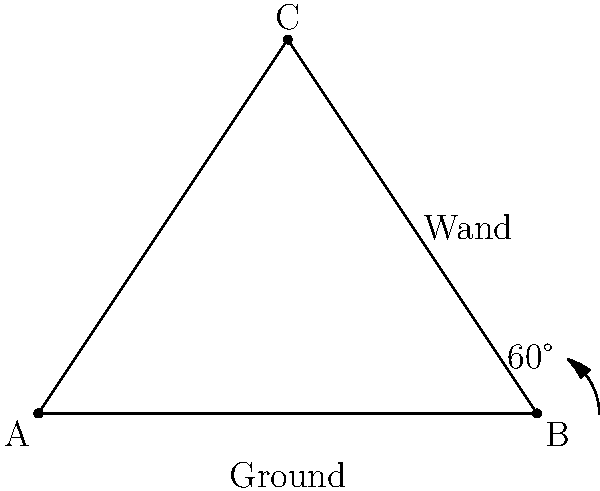In a classic Sabrina the Teenage Witch spell-casting scene, Sabrina holds her magic wand at a 60° angle to the ground. If the wand is 4 units long and forms a right triangle with the ground, what is the height of the wand's tip from the ground? Let's approach this step-by-step:

1) We have a right triangle where:
   - The hypotenuse (the wand) is 4 units long
   - One of the angles is 60°
   - The other angle (besides the right angle) must be 30° (since angles in a triangle sum to 180°)

2) We need to find the length of the opposite side to the 60° angle, which is the height of the wand's tip.

3) In a 30-60-90 triangle, the sides have a specific ratio:
   $1 : \sqrt{3} : 2$

4) The hypotenuse (longest side) is always twice the shortest side in this type of triangle.

5) So, if the hypotenuse (wand) is 4 units, the shortest side (half of the hypotenuse) is 2 units.

6) The height we're looking for is the side opposite to the 60° angle, which is the $\sqrt{3}$ in our ratio.

7) If 2 corresponds to 1 in our ratio, then the height will be:
   $2 \sqrt{3}$

Therefore, the height of the wand's tip from the ground is $2\sqrt{3}$ units.
Answer: $2\sqrt{3}$ units 